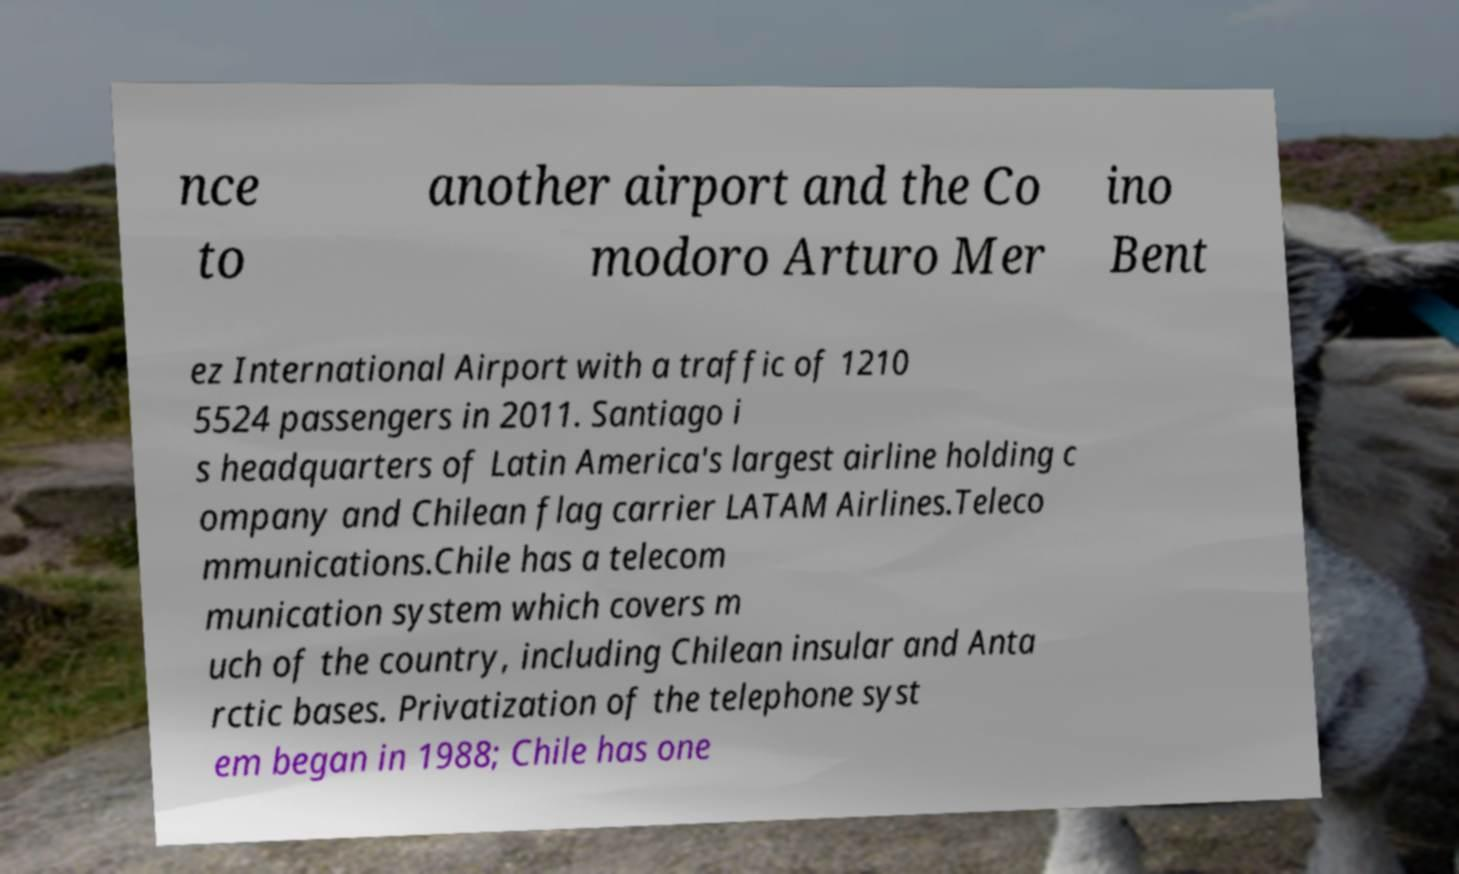Could you extract and type out the text from this image? nce to another airport and the Co modoro Arturo Mer ino Bent ez International Airport with a traffic of 1210 5524 passengers in 2011. Santiago i s headquarters of Latin America's largest airline holding c ompany and Chilean flag carrier LATAM Airlines.Teleco mmunications.Chile has a telecom munication system which covers m uch of the country, including Chilean insular and Anta rctic bases. Privatization of the telephone syst em began in 1988; Chile has one 